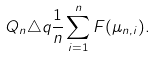Convert formula to latex. <formula><loc_0><loc_0><loc_500><loc_500>Q _ { n } \triangle q \frac { 1 } { n } \sum _ { i = 1 } ^ { n } F ( \mu _ { n , i } ) .</formula> 